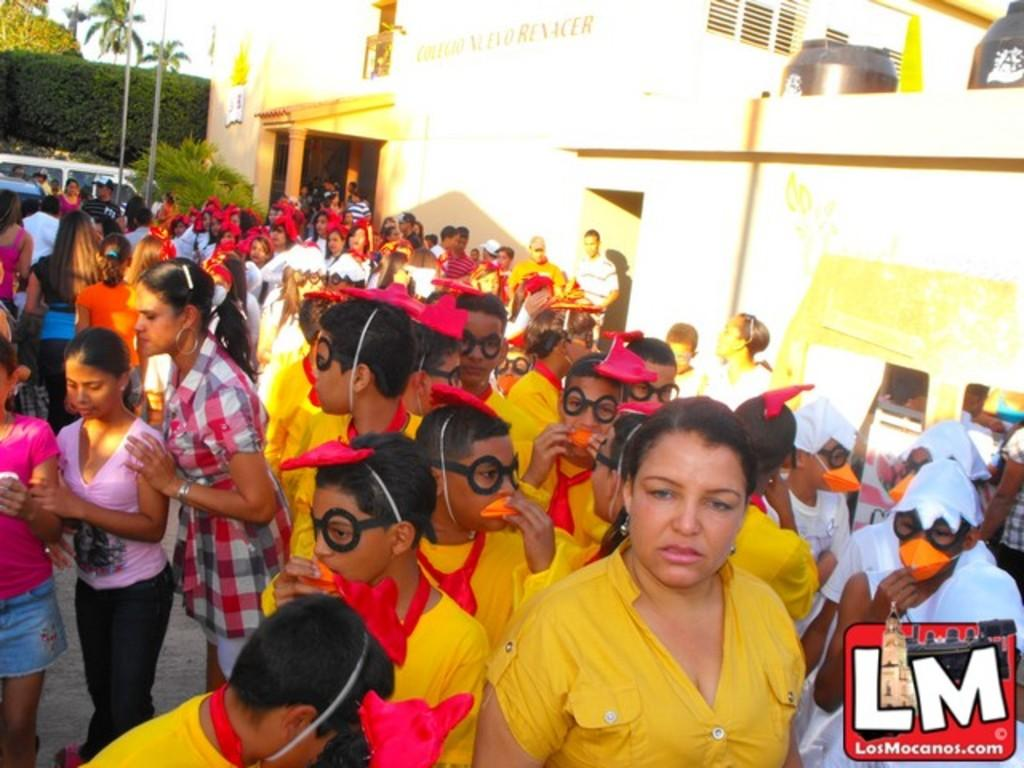What are the people in the image doing? There is a group of people standing on the ground. What architectural features can be seen in the image? There are pillars in the image. What type of structure is visible in the image? There is a building with windows in the image. What can be seen in the background of the image? There is a vehicle visible in the background and trees are present in the background. What type of pain is the group of people experiencing in the image? There is no indication of pain or discomfort in the image; the people are simply standing on the ground. 